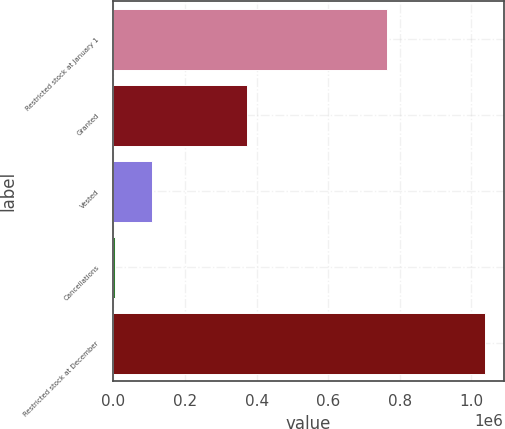<chart> <loc_0><loc_0><loc_500><loc_500><bar_chart><fcel>Restricted stock at January 1<fcel>Granted<fcel>Vested<fcel>Cancellations<fcel>Restricted stock at December<nl><fcel>764705<fcel>374455<fcel>108232<fcel>4895<fcel>1.03827e+06<nl></chart> 